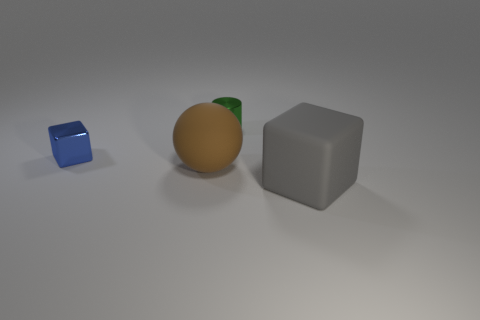The cylinder that is the same size as the blue thing is what color?
Ensure brevity in your answer.  Green. There is a metal thing that is behind the tiny blue metal block; what is its size?
Provide a short and direct response. Small. Are there any brown matte things on the right side of the big object that is behind the gray rubber cube?
Your answer should be very brief. No. Is the large thing that is behind the matte block made of the same material as the big gray cube?
Your answer should be very brief. Yes. How many cubes are right of the green shiny cylinder and on the left side of the gray rubber block?
Provide a succinct answer. 0. How many big gray things are the same material as the brown sphere?
Offer a terse response. 1. What color is the object that is made of the same material as the ball?
Provide a short and direct response. Gray. Are there fewer rubber cylinders than blue metallic things?
Provide a short and direct response. Yes. The big thing behind the large matte object on the right side of the tiny thing on the right side of the blue block is made of what material?
Make the answer very short. Rubber. What is the sphere made of?
Make the answer very short. Rubber. 